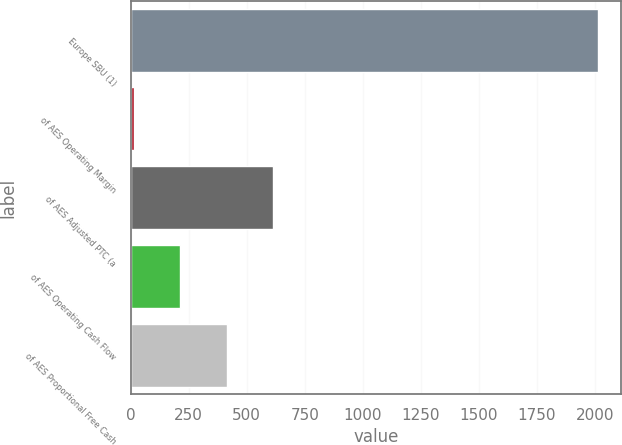Convert chart to OTSL. <chart><loc_0><loc_0><loc_500><loc_500><bar_chart><fcel>Europe SBU (1)<fcel>of AES Operating Margin<fcel>of AES Adjusted PTC (a<fcel>of AES Operating Cash Flow<fcel>of AES Proportional Free Cash<nl><fcel>2014<fcel>13<fcel>613.3<fcel>213.1<fcel>413.2<nl></chart> 